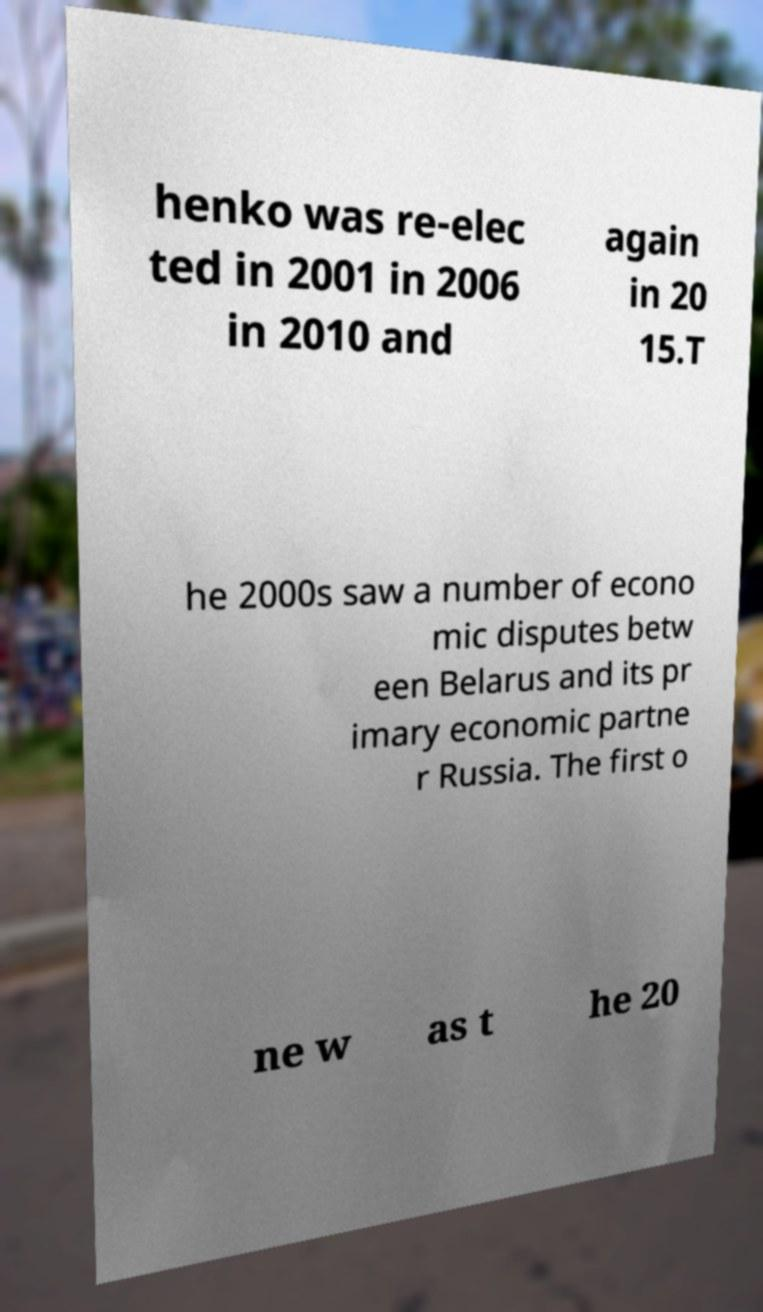There's text embedded in this image that I need extracted. Can you transcribe it verbatim? henko was re-elec ted in 2001 in 2006 in 2010 and again in 20 15.T he 2000s saw a number of econo mic disputes betw een Belarus and its pr imary economic partne r Russia. The first o ne w as t he 20 